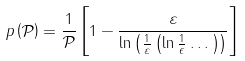Convert formula to latex. <formula><loc_0><loc_0><loc_500><loc_500>p \left ( \mathcal { P } \right ) = \frac { 1 } { \mathcal { P } } \left [ 1 - \frac { \varepsilon } { \ln \left ( \frac { 1 } { \varepsilon } \left ( \ln \frac { 1 } { \epsilon } \dots \right ) \right ) } \right ]</formula> 